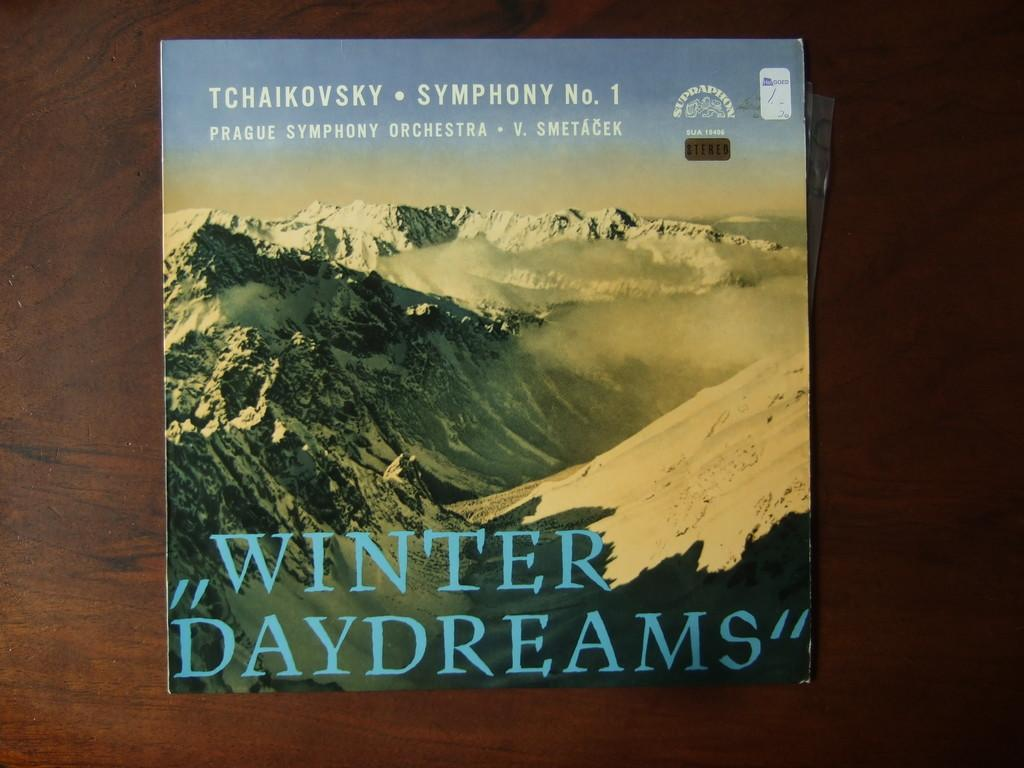What is the main object in the image? There is a wooden plank in the image. What is placed on the wooden plank? There is a magazine on the wooden plank. What is the name of the magazine? The magazine has the name "Winter Daydream" on it. What type of image is on the magazine? There is an image of mountains on the magazine. How many ladybugs can be seen crawling on the wooden plank in the image? There are no ladybugs present in the image; it only features a wooden plank, a magazine, and an image of mountains. 